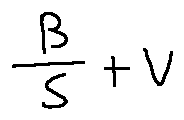<formula> <loc_0><loc_0><loc_500><loc_500>\frac { B } { S } + v</formula> 